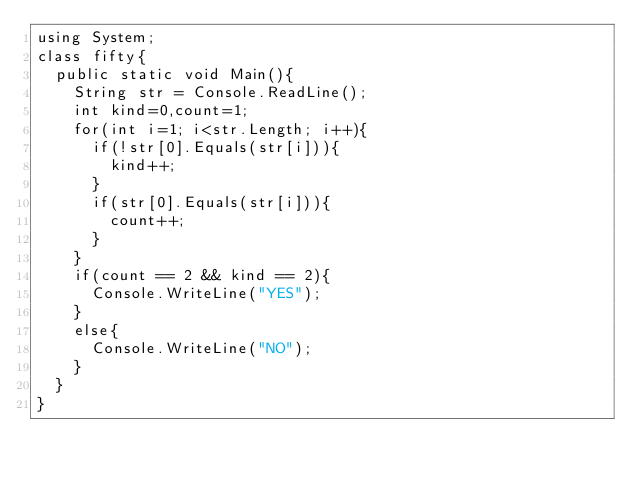Convert code to text. <code><loc_0><loc_0><loc_500><loc_500><_C#_>using System;
class fifty{
  public static void Main(){
    String str = Console.ReadLine();
    int kind=0,count=1;
    for(int i=1; i<str.Length; i++){
      if(!str[0].Equals(str[i])){
        kind++;
      }
      if(str[0].Equals(str[i])){
        count++;
      }
    }
    if(count == 2 && kind == 2){
      Console.WriteLine("YES");
    }
    else{
      Console.WriteLine("NO");
    }
  }
}
</code> 